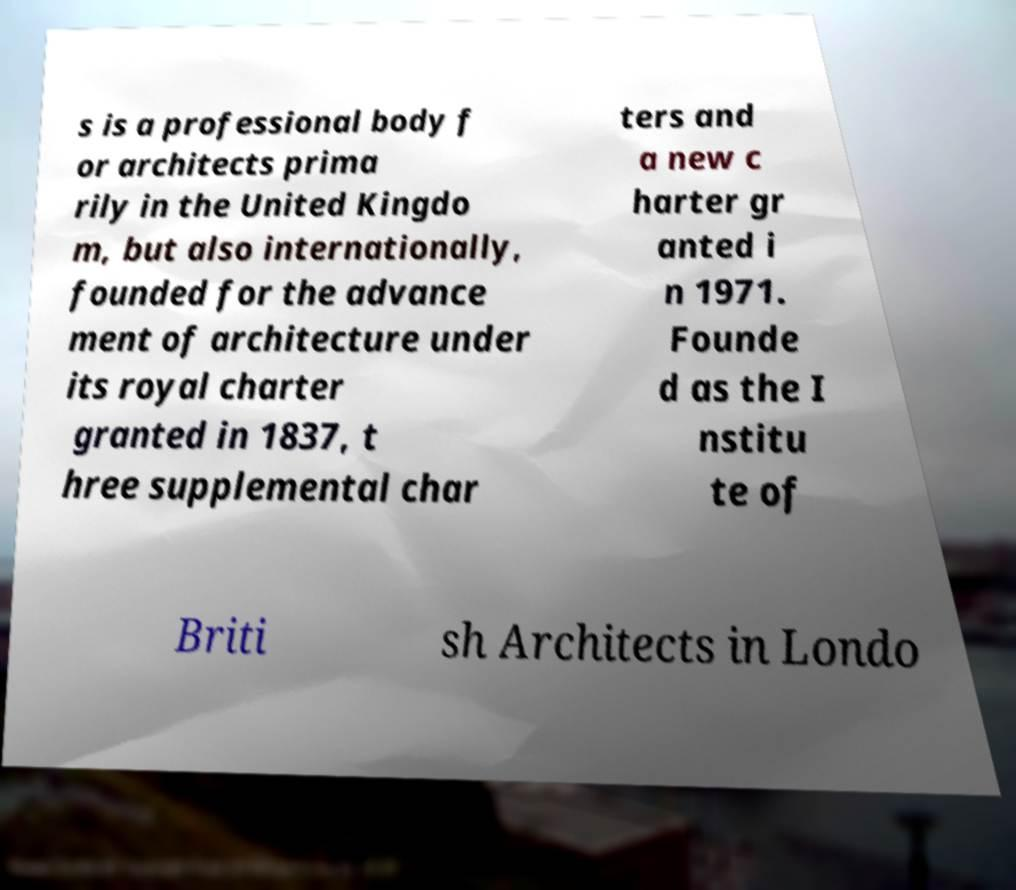Could you extract and type out the text from this image? s is a professional body f or architects prima rily in the United Kingdo m, but also internationally, founded for the advance ment of architecture under its royal charter granted in 1837, t hree supplemental char ters and a new c harter gr anted i n 1971. Founde d as the I nstitu te of Briti sh Architects in Londo 